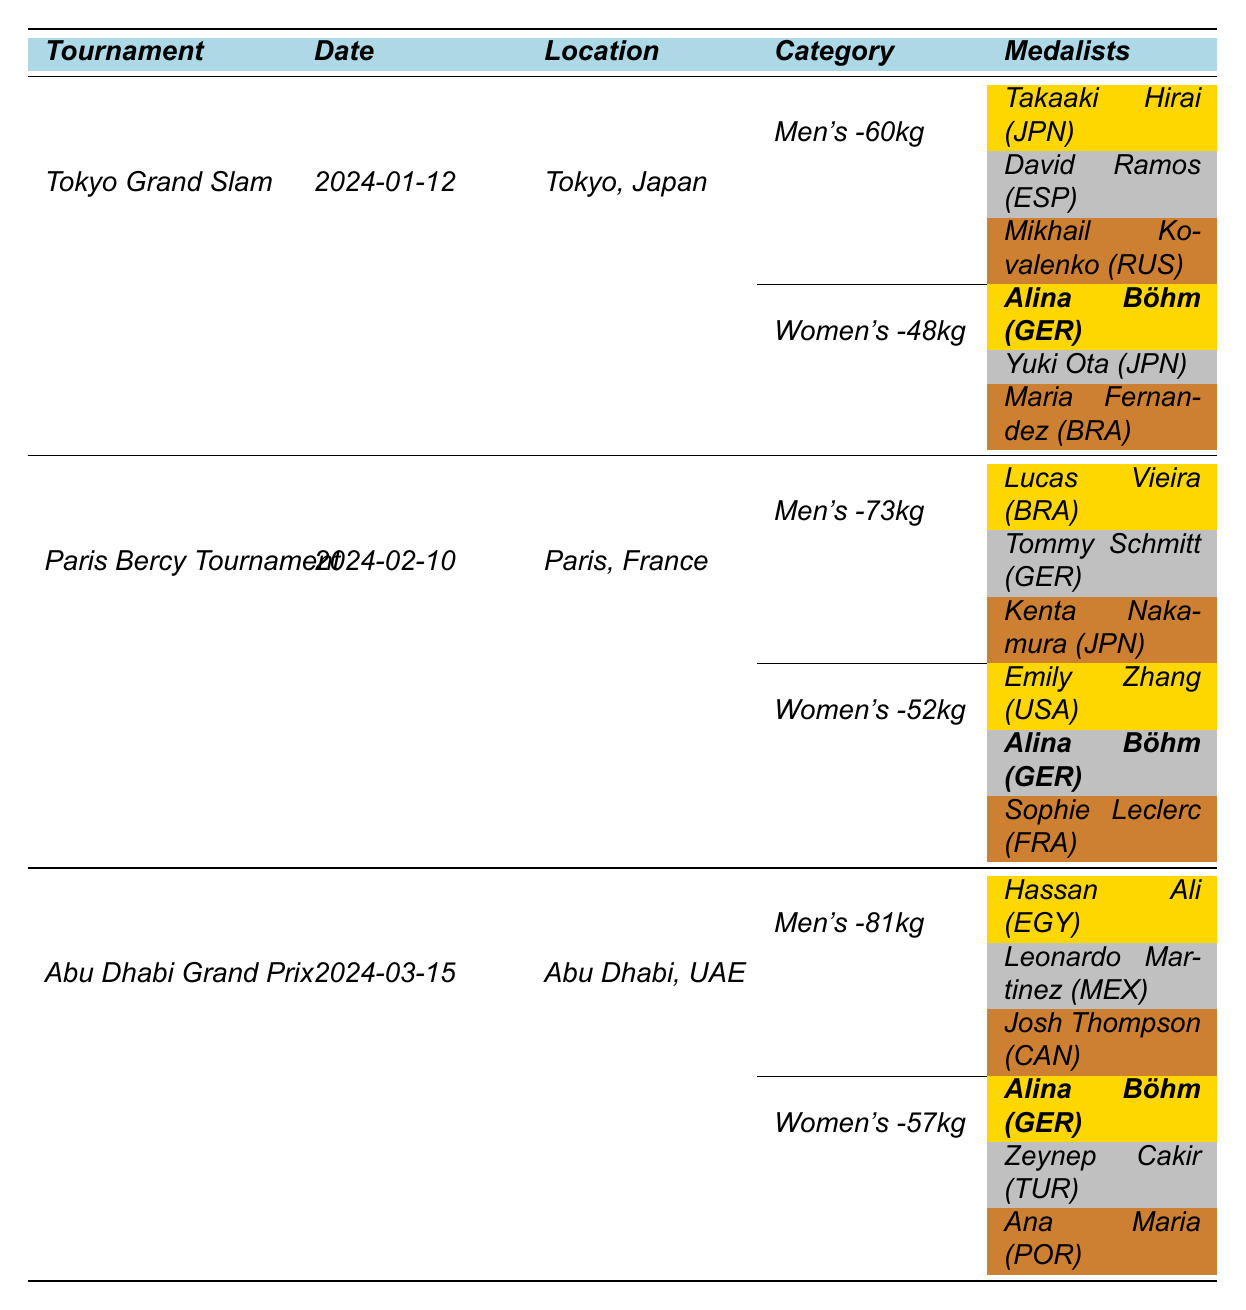What is the date of the Tokyo Grand Slam tournament? The table lists the date for the Tokyo Grand Slam tournament as "2024-01-12."
Answer: 2024-01-12 How many total events are listed for the Tokyo Grand Slam? The table shows two main categories under the Tokyo Grand Slam: Men's -60kg and Women's -48kg, thus there are two events.
Answer: 2 Who won the gold medal in the Women's -57kg category at the Abu Dhabi Grand Prix? The table indicates that Alina Böhm won the gold medal in the Women's -57kg category at the Abu Dhabi Grand Prix.
Answer: Alina Böhm Which country did the silver medalist in the Men's -60kg category represent? The table indicates that the silver medalist, David Ramos, represented Spain in the Men's -60kg category.
Answer: Spain Is Alina Böhm the only athlete listed as a medalist in more than one tournament? By reviewing the table, Alina Böhm is noted as a medalist in both the Tokyo Grand Slam and the Abu Dhabi Grand Prix.
Answer: Yes Which male athlete won the gold medal in the Men's -73kg category at the Paris Bercy Tournament? The table indicates that Lucas Vieira won the gold medal in the Men's -73kg category at the Paris Bercy Tournament.
Answer: Lucas Vieira How many total gold medals did Alina Böhm win across the three tournaments? Alina Böhm won gold in the Women's -48kg at the Tokyo Grand Slam and the Women's -57kg at the Abu Dhabi Grand Prix, totaling two gold medals.
Answer: 2 What is the difference in weight categories between Alina Böhm's events? Alina Böhm competed in the Women's -48kg and Women's -57kg categories, which is a difference of 9kg.
Answer: 9kg In which tournament did the gold medalist of the Men's -81kg category compete? The gold medalist of the Men's -81kg category, Hassan Ali, competed at the Abu Dhabi Grand Prix.
Answer: Abu Dhabi Grand Prix How many medalists were from Japan in the Women's -48kg event at the Tokyo Grand Slam? In the Women's -48kg event, only one medalist, Yuki Ota, was from Japan (the silver medalist), while Alina Böhm and Maria Fernandez represented Germany and Brazil, respectively.
Answer: 1 